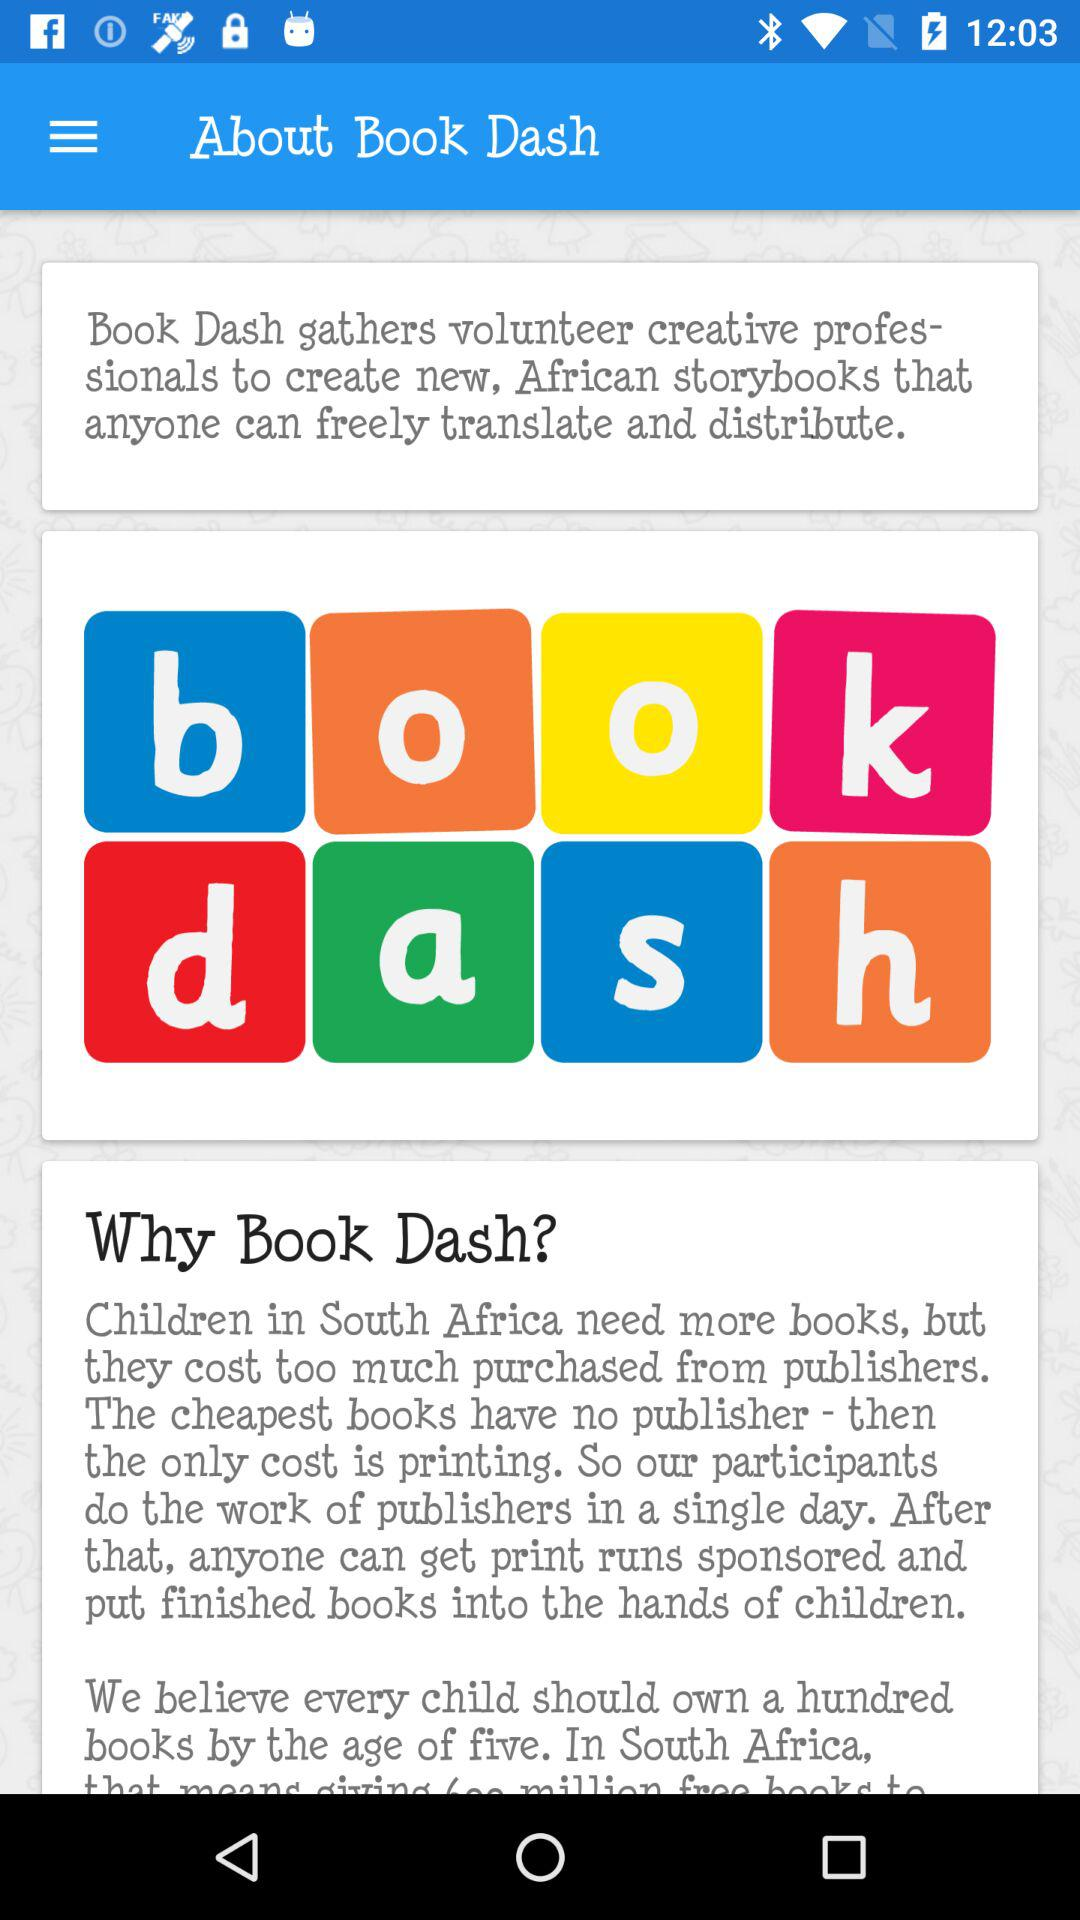What is the app name? The app name is "Book Dash". 